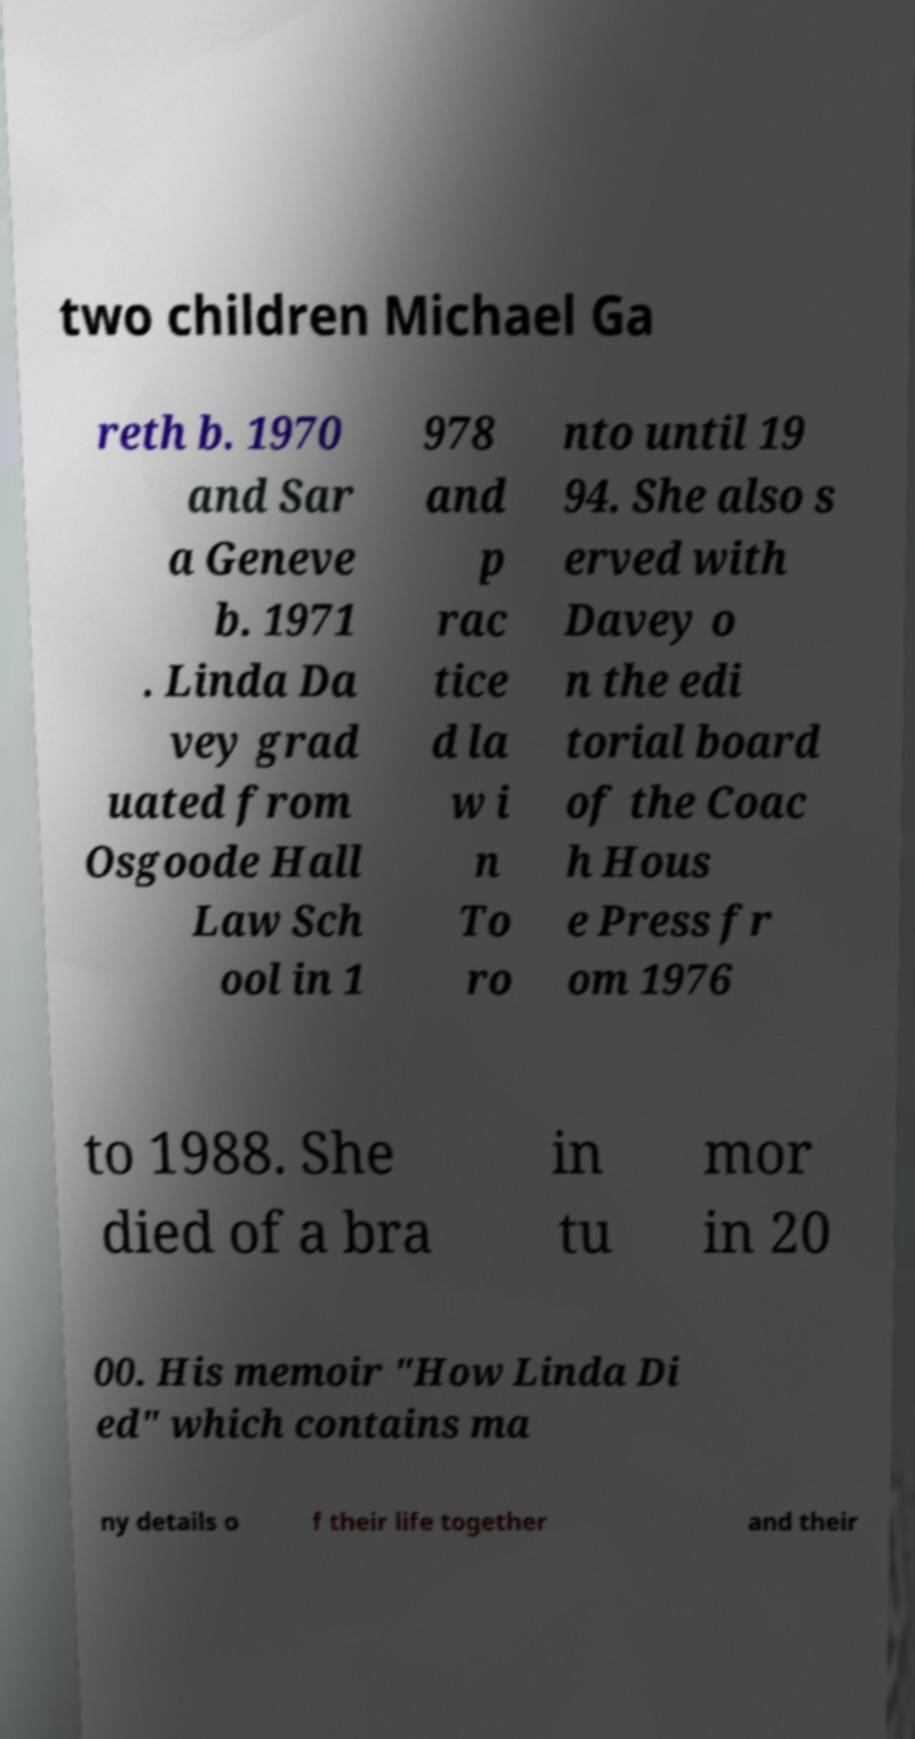Can you read and provide the text displayed in the image?This photo seems to have some interesting text. Can you extract and type it out for me? two children Michael Ga reth b. 1970 and Sar a Geneve b. 1971 . Linda Da vey grad uated from Osgoode Hall Law Sch ool in 1 978 and p rac tice d la w i n To ro nto until 19 94. She also s erved with Davey o n the edi torial board of the Coac h Hous e Press fr om 1976 to 1988. She died of a bra in tu mor in 20 00. His memoir "How Linda Di ed" which contains ma ny details o f their life together and their 